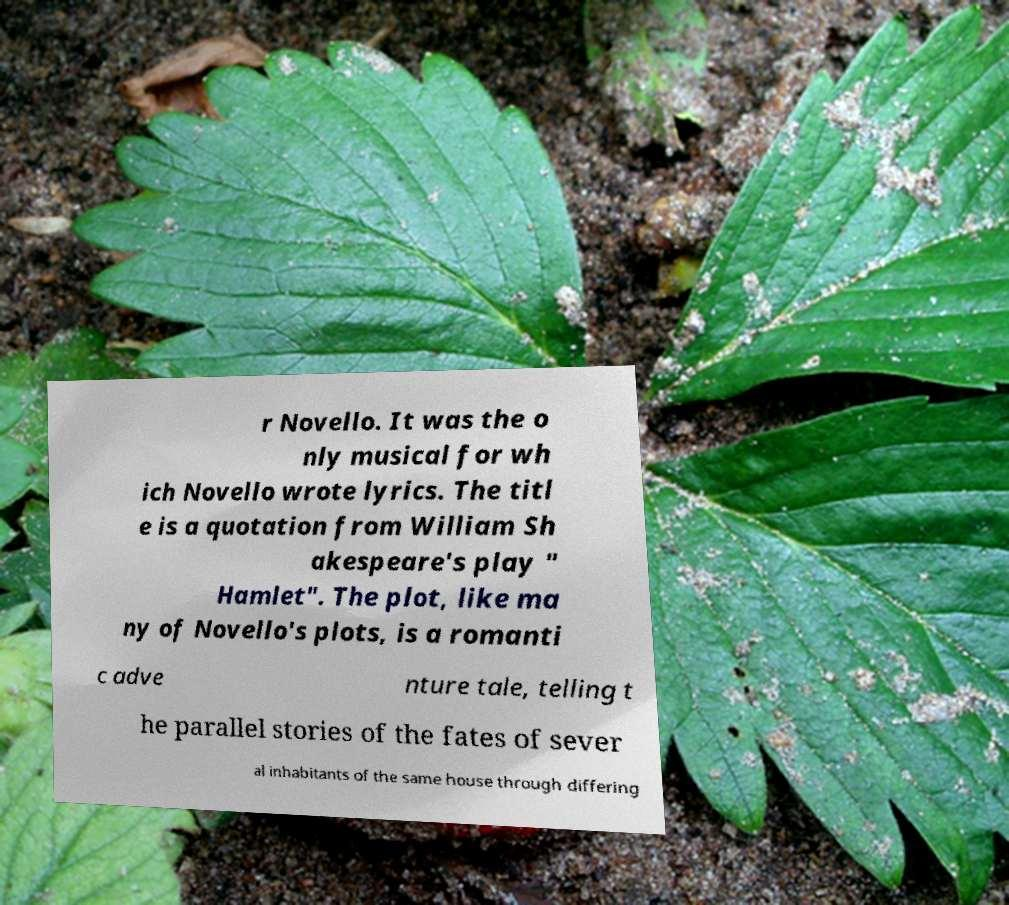Could you extract and type out the text from this image? r Novello. It was the o nly musical for wh ich Novello wrote lyrics. The titl e is a quotation from William Sh akespeare's play " Hamlet". The plot, like ma ny of Novello's plots, is a romanti c adve nture tale, telling t he parallel stories of the fates of sever al inhabitants of the same house through differing 